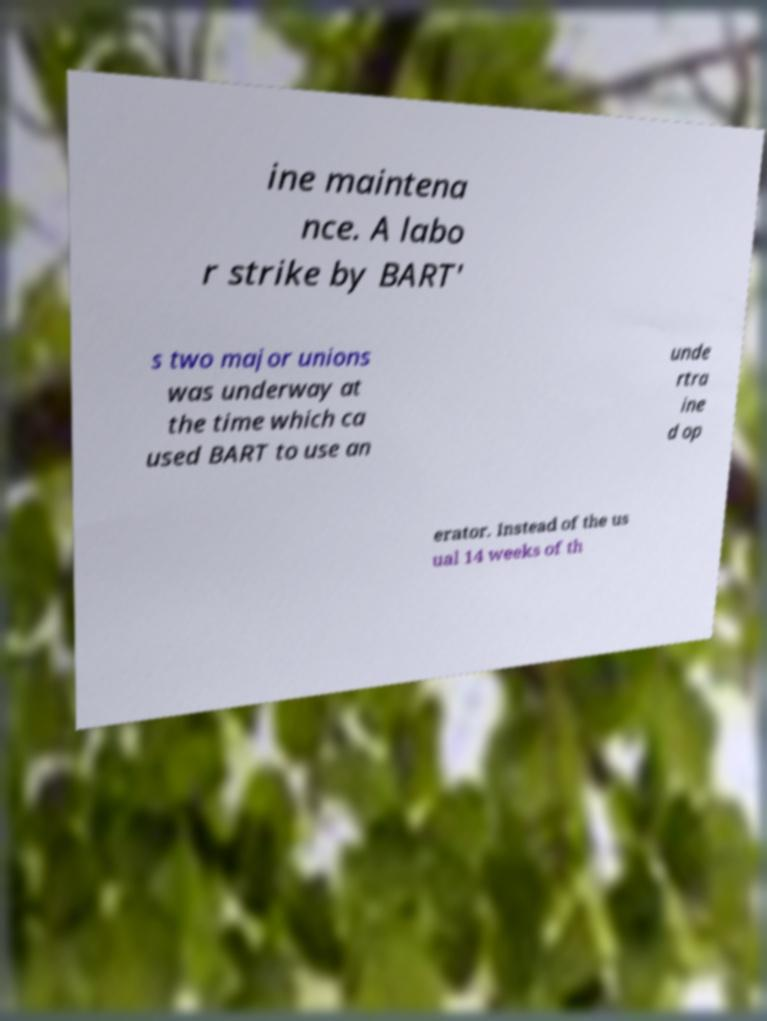For documentation purposes, I need the text within this image transcribed. Could you provide that? ine maintena nce. A labo r strike by BART' s two major unions was underway at the time which ca used BART to use an unde rtra ine d op erator. Instead of the us ual 14 weeks of th 